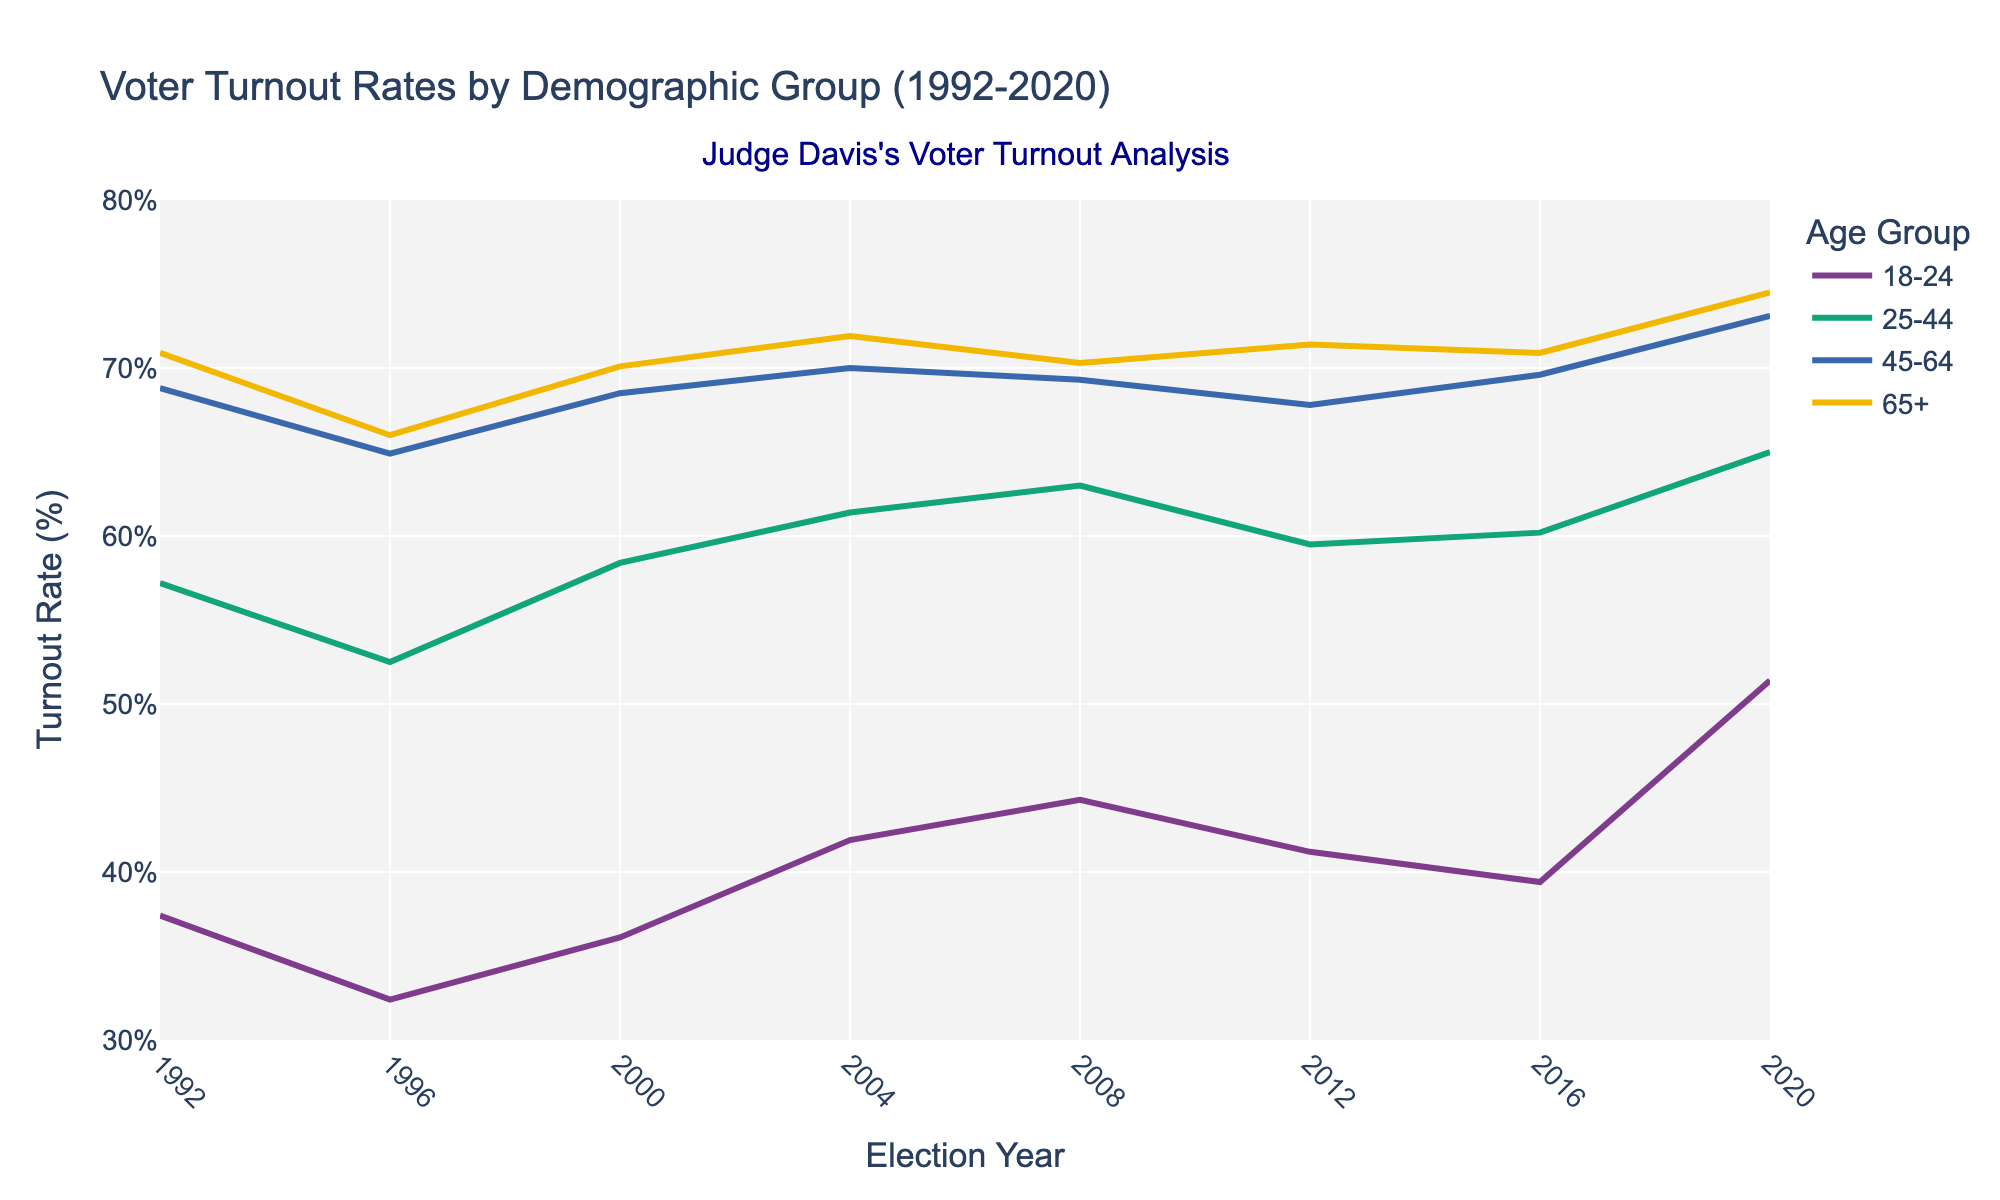What is the title of the figure? The title is prominently displayed at the top of the figure. It reads "Voter Turnout Rates by Demographic Group (1992-2020)."
Answer: Voter Turnout Rates by Demographic Group (1992-2020) Which demographic group had the highest voter turnout rate in 2020? By referring to the point in 2020 for each demographic group, the 65+ group had the highest voter turnout rate, marked at 74.5%.
Answer: 65+ What is the overall trend for the 18-24 demographic group from 1992 to 2020? The line for the 18-24 group shows fluctuations over the years, but a general upward trend can be noted with a significant jump in 2020.
Answer: Upward trend How does the voter turnout rate for the 25-44 age group in 2008 compare to that in 2012? Examining the points for the 25-44 age group in 2008 and 2012, the rate decreased from 63.0% in 2008 to 59.5% in 2012.
Answer: Decreased Which year showed the lowest voter turnout rate for the 65+ demographic group, and what was the rate? By analyzing the points for the 65+ group across all years, the lowest rate was in 1996 at 66.0%.
Answer: 1996, 66.0% What is the range of voter turnout rates for the 45-64 demographic group between 1992 and 2020? Identifying the lowest and highest points for the 45-64 group, the lowest rate is 64.9% (1996), and the highest is 73.1% (2020), so the range is 73.1% - 64.9% = 8.2%.
Answer: 8.2% In which election years did the 25-44 demographic group show an increase in voter turnout rates as compared to the previous election year? By tracking the points for the 25-44 group year by year, increases are noted in 2000 (increase from 1996), 2004 (increase from 2000), 2008 (increase from 2004), and 2020 (increase from 2016).
Answer: 2000, 2004, 2008, 2020 What is the average voter turnout rate for the 18-24 demographic group over the entire period? Sum the voter turnout rates for the 18-24 group for all years and divide by the number of years: (37.4 + 32.4 + 36.1 + 41.9 + 44.3 + 41.2 + 39.4 + 51.4) / 8 = 40.5125%.
Answer: 40.5125% Across all years, which demographic group consistently had the highest voter turnout rate? Observing the highest points in the graph from each year, the 65+ group consistently shows the highest voter turnout rates compared to other groups.
Answer: 65+ 